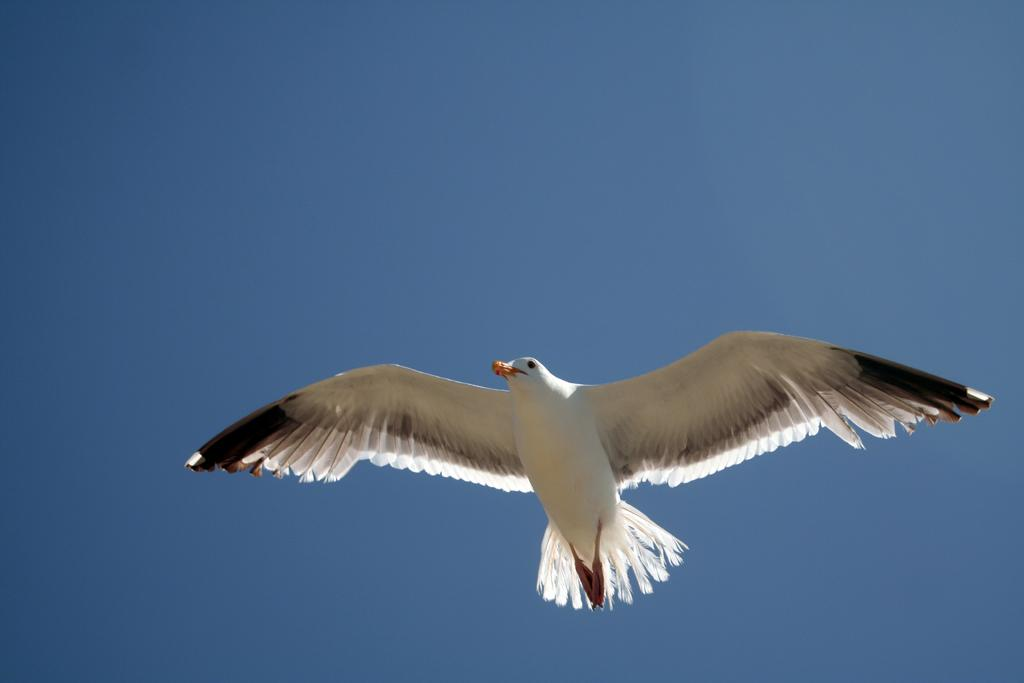What is the main subject of the image? The main subject of the image is a bird flying. What can be seen in the background of the image? The sky is visible in the background of the image. What type of body is visible in the image? There is no body present in the image; it features a bird flying in the sky. How many pigs can be seen in the image? There are no pigs present in the image. 